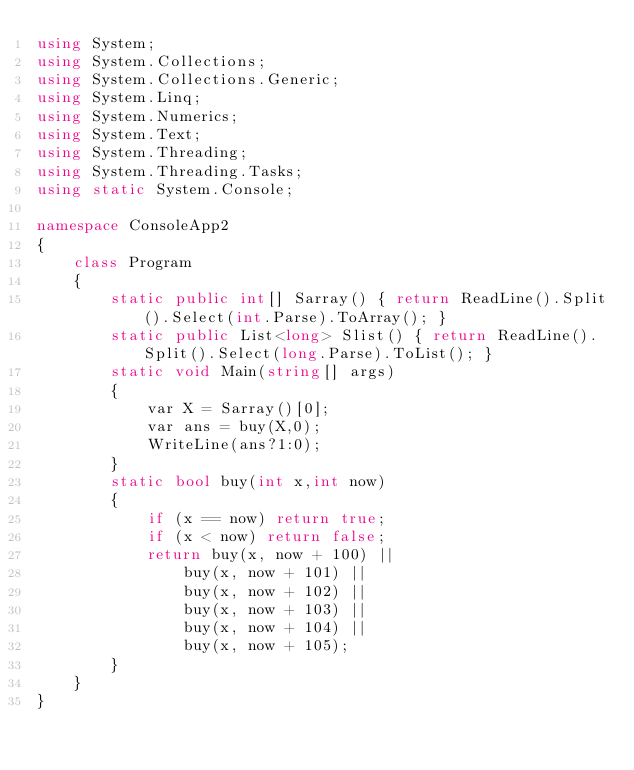<code> <loc_0><loc_0><loc_500><loc_500><_C#_>using System;
using System.Collections;
using System.Collections.Generic;
using System.Linq;
using System.Numerics;
using System.Text;
using System.Threading;
using System.Threading.Tasks;
using static System.Console;

namespace ConsoleApp2
{
    class Program
    {
        static public int[] Sarray() { return ReadLine().Split().Select(int.Parse).ToArray(); }
        static public List<long> Slist() { return ReadLine().Split().Select(long.Parse).ToList(); }
        static void Main(string[] args)
        {
            var X = Sarray()[0];
            var ans = buy(X,0);
            WriteLine(ans?1:0);
        }
        static bool buy(int x,int now)
        {
            if (x == now) return true;
            if (x < now) return false;
            return buy(x, now + 100) ||
                buy(x, now + 101) ||
                buy(x, now + 102) ||
                buy(x, now + 103) ||
                buy(x, now + 104) ||
                buy(x, now + 105);
        }
    }
}</code> 